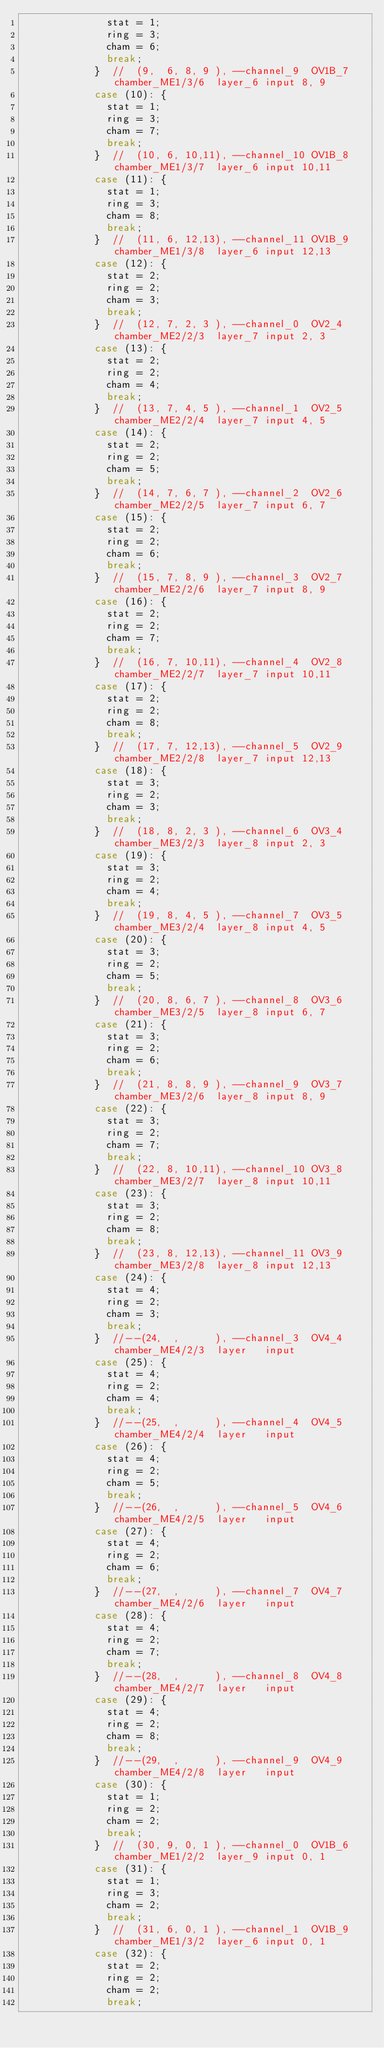Convert code to text. <code><loc_0><loc_0><loc_500><loc_500><_C++_>              stat = 1;
              ring = 3;
              cham = 6;
              break;
            }  //  (9,  6, 8, 9 ), --channel_9  OV1B_7 chamber_ME1/3/6  layer_6 input 8, 9
            case (10): {
              stat = 1;
              ring = 3;
              cham = 7;
              break;
            }  //  (10, 6, 10,11), --channel_10 OV1B_8 chamber_ME1/3/7  layer_6 input 10,11
            case (11): {
              stat = 1;
              ring = 3;
              cham = 8;
              break;
            }  //  (11, 6, 12,13), --channel_11 OV1B_9 chamber_ME1/3/8  layer_6 input 12,13
            case (12): {
              stat = 2;
              ring = 2;
              cham = 3;
              break;
            }  //  (12, 7, 2, 3 ), --channel_0  OV2_4  chamber_ME2/2/3  layer_7 input 2, 3
            case (13): {
              stat = 2;
              ring = 2;
              cham = 4;
              break;
            }  //  (13, 7, 4, 5 ), --channel_1  OV2_5  chamber_ME2/2/4  layer_7 input 4, 5
            case (14): {
              stat = 2;
              ring = 2;
              cham = 5;
              break;
            }  //  (14, 7, 6, 7 ), --channel_2  OV2_6  chamber_ME2/2/5  layer_7 input 6, 7
            case (15): {
              stat = 2;
              ring = 2;
              cham = 6;
              break;
            }  //  (15, 7, 8, 9 ), --channel_3  OV2_7  chamber_ME2/2/6  layer_7 input 8, 9
            case (16): {
              stat = 2;
              ring = 2;
              cham = 7;
              break;
            }  //  (16, 7, 10,11), --channel_4  OV2_8  chamber_ME2/2/7  layer_7 input 10,11
            case (17): {
              stat = 2;
              ring = 2;
              cham = 8;
              break;
            }  //  (17, 7, 12,13), --channel_5  OV2_9  chamber_ME2/2/8  layer_7 input 12,13
            case (18): {
              stat = 3;
              ring = 2;
              cham = 3;
              break;
            }  //  (18, 8, 2, 3 ), --channel_6  OV3_4  chamber_ME3/2/3  layer_8 input 2, 3
            case (19): {
              stat = 3;
              ring = 2;
              cham = 4;
              break;
            }  //  (19, 8, 4, 5 ), --channel_7  OV3_5  chamber_ME3/2/4  layer_8 input 4, 5
            case (20): {
              stat = 3;
              ring = 2;
              cham = 5;
              break;
            }  //  (20, 8, 6, 7 ), --channel_8  OV3_6  chamber_ME3/2/5  layer_8 input 6, 7
            case (21): {
              stat = 3;
              ring = 2;
              cham = 6;
              break;
            }  //  (21, 8, 8, 9 ), --channel_9  OV3_7  chamber_ME3/2/6  layer_8 input 8, 9
            case (22): {
              stat = 3;
              ring = 2;
              cham = 7;
              break;
            }  //  (22, 8, 10,11), --channel_10 OV3_8  chamber_ME3/2/7  layer_8 input 10,11
            case (23): {
              stat = 3;
              ring = 2;
              cham = 8;
              break;
            }  //  (23, 8, 12,13), --channel_11 OV3_9  chamber_ME3/2/8  layer_8 input 12,13
            case (24): {
              stat = 4;
              ring = 2;
              cham = 3;
              break;
            }  //--(24,  ,      ), --channel_3  OV4_4  chamber_ME4/2/3  layer   input
            case (25): {
              stat = 4;
              ring = 2;
              cham = 4;
              break;
            }  //--(25,  ,      ), --channel_4  OV4_5  chamber_ME4/2/4  layer   input
            case (26): {
              stat = 4;
              ring = 2;
              cham = 5;
              break;
            }  //--(26,  ,      ), --channel_5  OV4_6  chamber_ME4/2/5  layer   input
            case (27): {
              stat = 4;
              ring = 2;
              cham = 6;
              break;
            }  //--(27,  ,      ), --channel_7  OV4_7  chamber_ME4/2/6  layer   input
            case (28): {
              stat = 4;
              ring = 2;
              cham = 7;
              break;
            }  //--(28,  ,      ), --channel_8  OV4_8  chamber_ME4/2/7  layer   input
            case (29): {
              stat = 4;
              ring = 2;
              cham = 8;
              break;
            }  //--(29,  ,      ), --channel_9  OV4_9  chamber_ME4/2/8  layer   input
            case (30): {
              stat = 1;
              ring = 2;
              cham = 2;
              break;
            }  //  (30, 9, 0, 1 ), --channel_0  OV1B_6 chamber_ME1/2/2  layer_9 input 0, 1
            case (31): {
              stat = 1;
              ring = 3;
              cham = 2;
              break;
            }  //  (31, 6, 0, 1 ), --channel_1  OV1B_9 chamber_ME1/3/2  layer_6 input 0, 1
            case (32): {
              stat = 2;
              ring = 2;
              cham = 2;
              break;</code> 